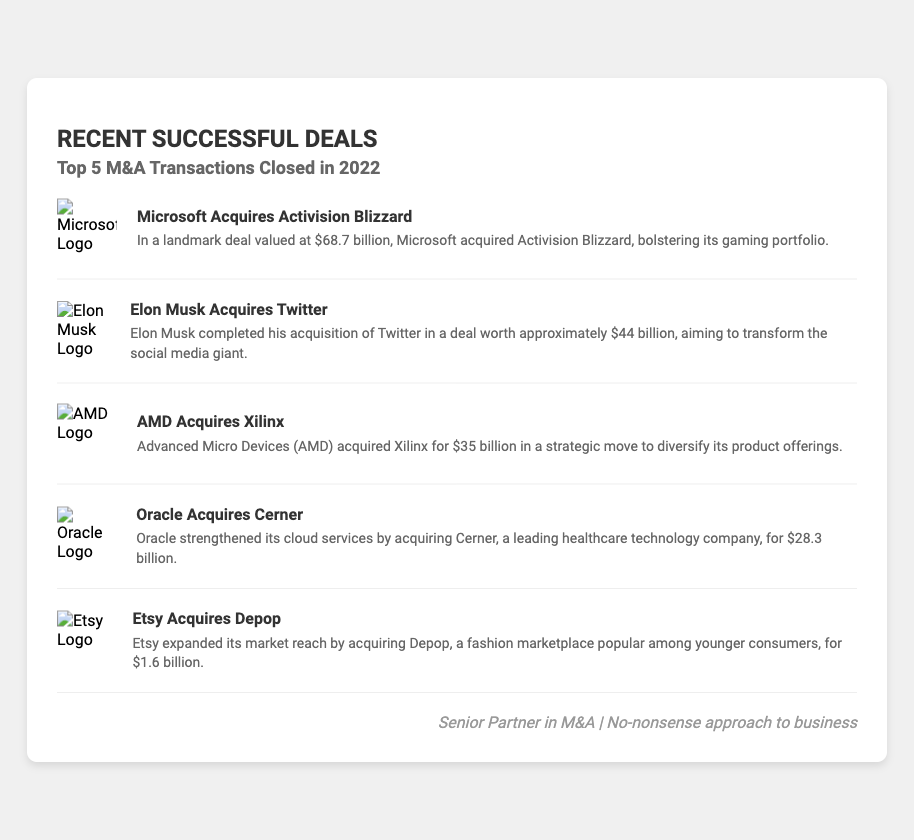what is the total value of the Microsoft acquisition? The total value of the Microsoft acquisition is specified as $68.7 billion in the document.
Answer: $68.7 billion who acquired Twitter? The document states that Elon Musk is the individual who acquired Twitter.
Answer: Elon Musk what was the value of the AMD acquisition? The value of the AMD acquisition of Xilinx is indicated as $35 billion in the document.
Answer: $35 billion which company did Etsy acquire? The document specifies that Etsy acquired Depop.
Answer: Depop how many transactions are listed in the document? The document lists a total of five M&A transactions.
Answer: Five what is the purpose of Microsoft's acquisition of Activision Blizzard? The document mentions that the acquisition aims to bolster Microsoft's gaming portfolio.
Answer: Bolster its gaming portfolio what is the total number of logos displayed in the card? The document includes five logos representing each transaction.
Answer: Five what is the acquisition price for Cerner by Oracle? The acquisition price for Cerner by Oracle is stated as $28.3 billion in the document.
Answer: $28.3 billion which company acquired Xilinx? The document identifies AMD as the company that acquired Xilinx.
Answer: AMD 